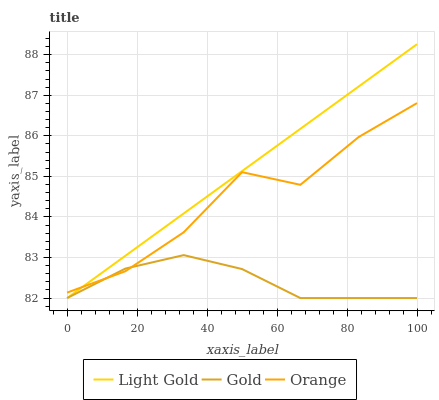Does Gold have the minimum area under the curve?
Answer yes or no. Yes. Does Light Gold have the maximum area under the curve?
Answer yes or no. Yes. Does Light Gold have the minimum area under the curve?
Answer yes or no. No. Does Gold have the maximum area under the curve?
Answer yes or no. No. Is Light Gold the smoothest?
Answer yes or no. Yes. Is Orange the roughest?
Answer yes or no. Yes. Is Gold the smoothest?
Answer yes or no. No. Is Gold the roughest?
Answer yes or no. No. Does Light Gold have the lowest value?
Answer yes or no. Yes. Does Light Gold have the highest value?
Answer yes or no. Yes. Does Gold have the highest value?
Answer yes or no. No. Does Orange intersect Light Gold?
Answer yes or no. Yes. Is Orange less than Light Gold?
Answer yes or no. No. Is Orange greater than Light Gold?
Answer yes or no. No. 